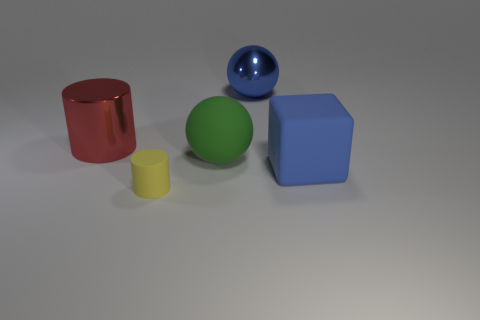Add 2 large green objects. How many objects exist? 7 Subtract all blue balls. How many balls are left? 1 Subtract all cubes. How many objects are left? 4 Subtract all big blue spheres. Subtract all rubber cubes. How many objects are left? 3 Add 4 blue rubber cubes. How many blue rubber cubes are left? 5 Add 1 metallic cylinders. How many metallic cylinders exist? 2 Subtract 0 gray cylinders. How many objects are left? 5 